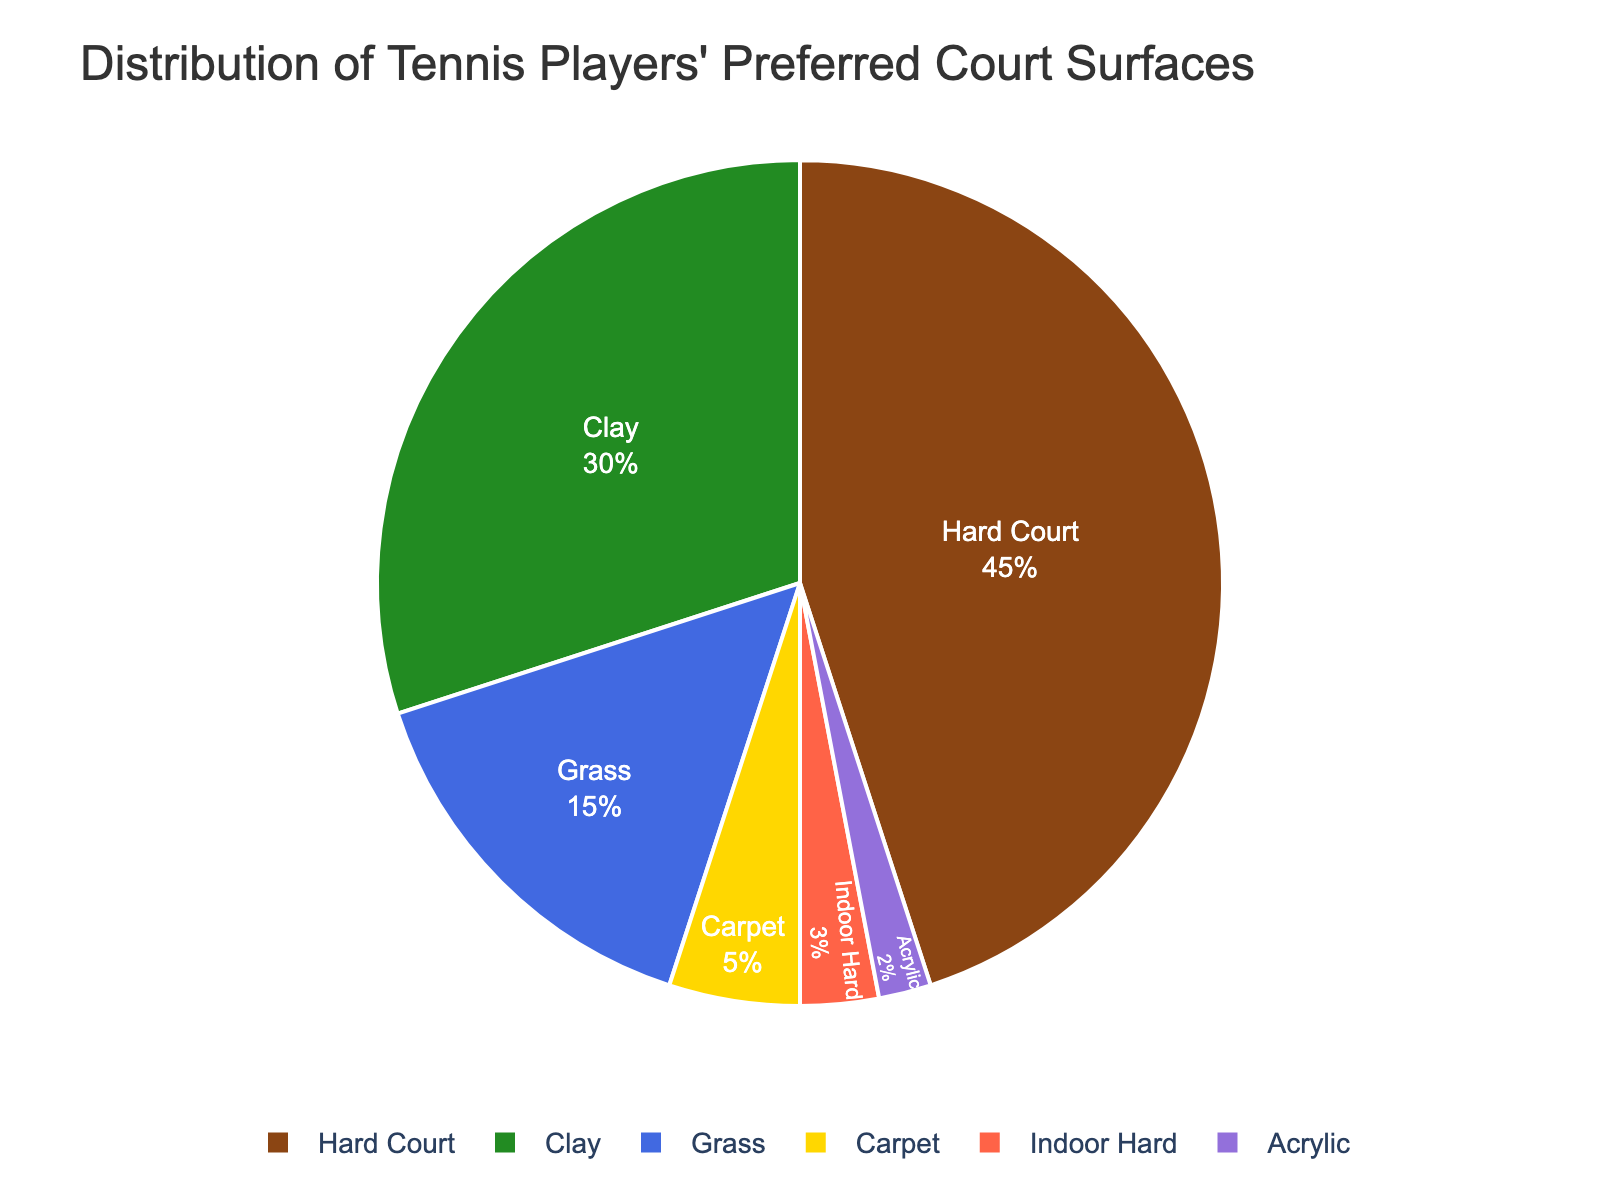What percentage of tennis players prefer Hard Court? The figure shows the distribution of tennis players' preferred court surfaces with Hard Court contributing 45%.
Answer: 45% Which court surface is least preferred by tennis players? By examining the segments of the pie chart, Acrylic has the smallest segment, indicating it's the least preferred surface.
Answer: Acrylic How much more popular is Hard Court compared to Clay? The percentage of players who prefer Hard Court is 45%, while for Clay it's 30%. The difference is 45% - 30%.
Answer: 15% What is the combined percentage of players who prefer Indoor Hard and Carpet surfaces? The percentages for Indoor Hard and Carpet surfaces are 3% and 5%, respectively. Adding them gives 3% + 5%.
Answer: 8% Which surface types account for less than 20% collectively? The data shows the percentages for Carpet, Indoor Hard, and Acrylic are 5%, 3%, and 2%, respectively. Summing these up gives 10%. They represent less than 20% collectively.
Answer: Carpet, Indoor Hard, Acrylic Out of the Hard Court and Grass surfaces, which is preferred by more players? The percentage for Hard Court is 45% and for Grass it is 15%. Hard Court has a larger percentage.
Answer: Hard Court By how much does the preference for Grass court exceed the preference for Acrylic court? Grass court is preferred by 15% of players while Acrylic court is preferred by 2% of players. The excess is 15% - 2%.
Answer: 13% If the percentages are ranked in descending order, what position does Clay surface hold? The percentages in descending order are 45% (Hard Court), 30% (Clay), 15% (Grass), 5% (Carpet), 3% (Indoor Hard), and 2% (Acrylic). Clay is in the second position.
Answer: Second Calculate the average percentage preference for Hard Court, Clay, and Grass surfaces. The percentages for these surfaces are 45%, 30%, and 15%. The average is (45% + 30% + 15%) / 3.
Answer: 30% What is the percentage difference between the most preferred and the least preferred court surfaces? The most preferred surface is Hard Court at 45%, and the least preferred is Acrylic at 2%. The percentage difference is 45% - 2%.
Answer: 43% 